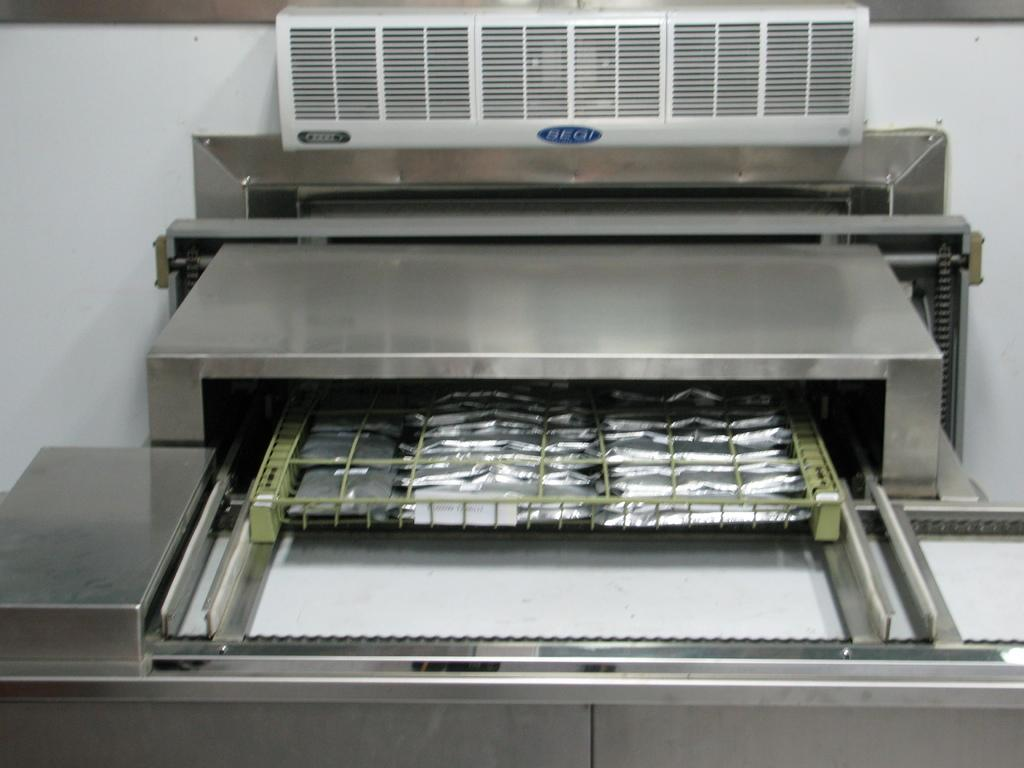What is the main object in the image? There is a machine in the image. What feature does the machine have? The machine has a conveyor belt. What is placed on the conveyor belt? There is a tray in the middle of the conveyor belt. What can be seen on the wall in the background? There appears to be an air vent on the wall in the background. What type of curve can be seen on the wrench in the image? There is no wrench present in the image, so it is not possible to determine if there is a curve on it. 